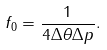<formula> <loc_0><loc_0><loc_500><loc_500>f _ { 0 } = \frac { 1 } { 4 \Delta \theta \Delta p } .</formula> 